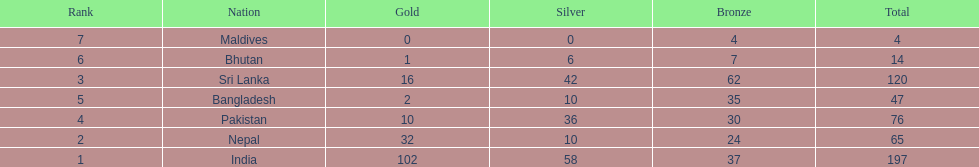Parse the full table. {'header': ['Rank', 'Nation', 'Gold', 'Silver', 'Bronze', 'Total'], 'rows': [['7', 'Maldives', '0', '0', '4', '4'], ['6', 'Bhutan', '1', '6', '7', '14'], ['3', 'Sri Lanka', '16', '42', '62', '120'], ['5', 'Bangladesh', '2', '10', '35', '47'], ['4', 'Pakistan', '10', '36', '30', '76'], ['2', 'Nepal', '32', '10', '24', '65'], ['1', 'India', '102', '58', '37', '197']]} How many countries have one more than 10 gold medals? 3. 